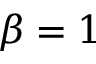<formula> <loc_0><loc_0><loc_500><loc_500>\beta = 1</formula> 